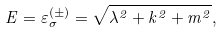<formula> <loc_0><loc_0><loc_500><loc_500>E = \varepsilon _ { \sigma } ^ { ( \pm ) } = \sqrt { \lambda ^ { 2 } + k ^ { 2 } + m ^ { 2 } } ,</formula> 